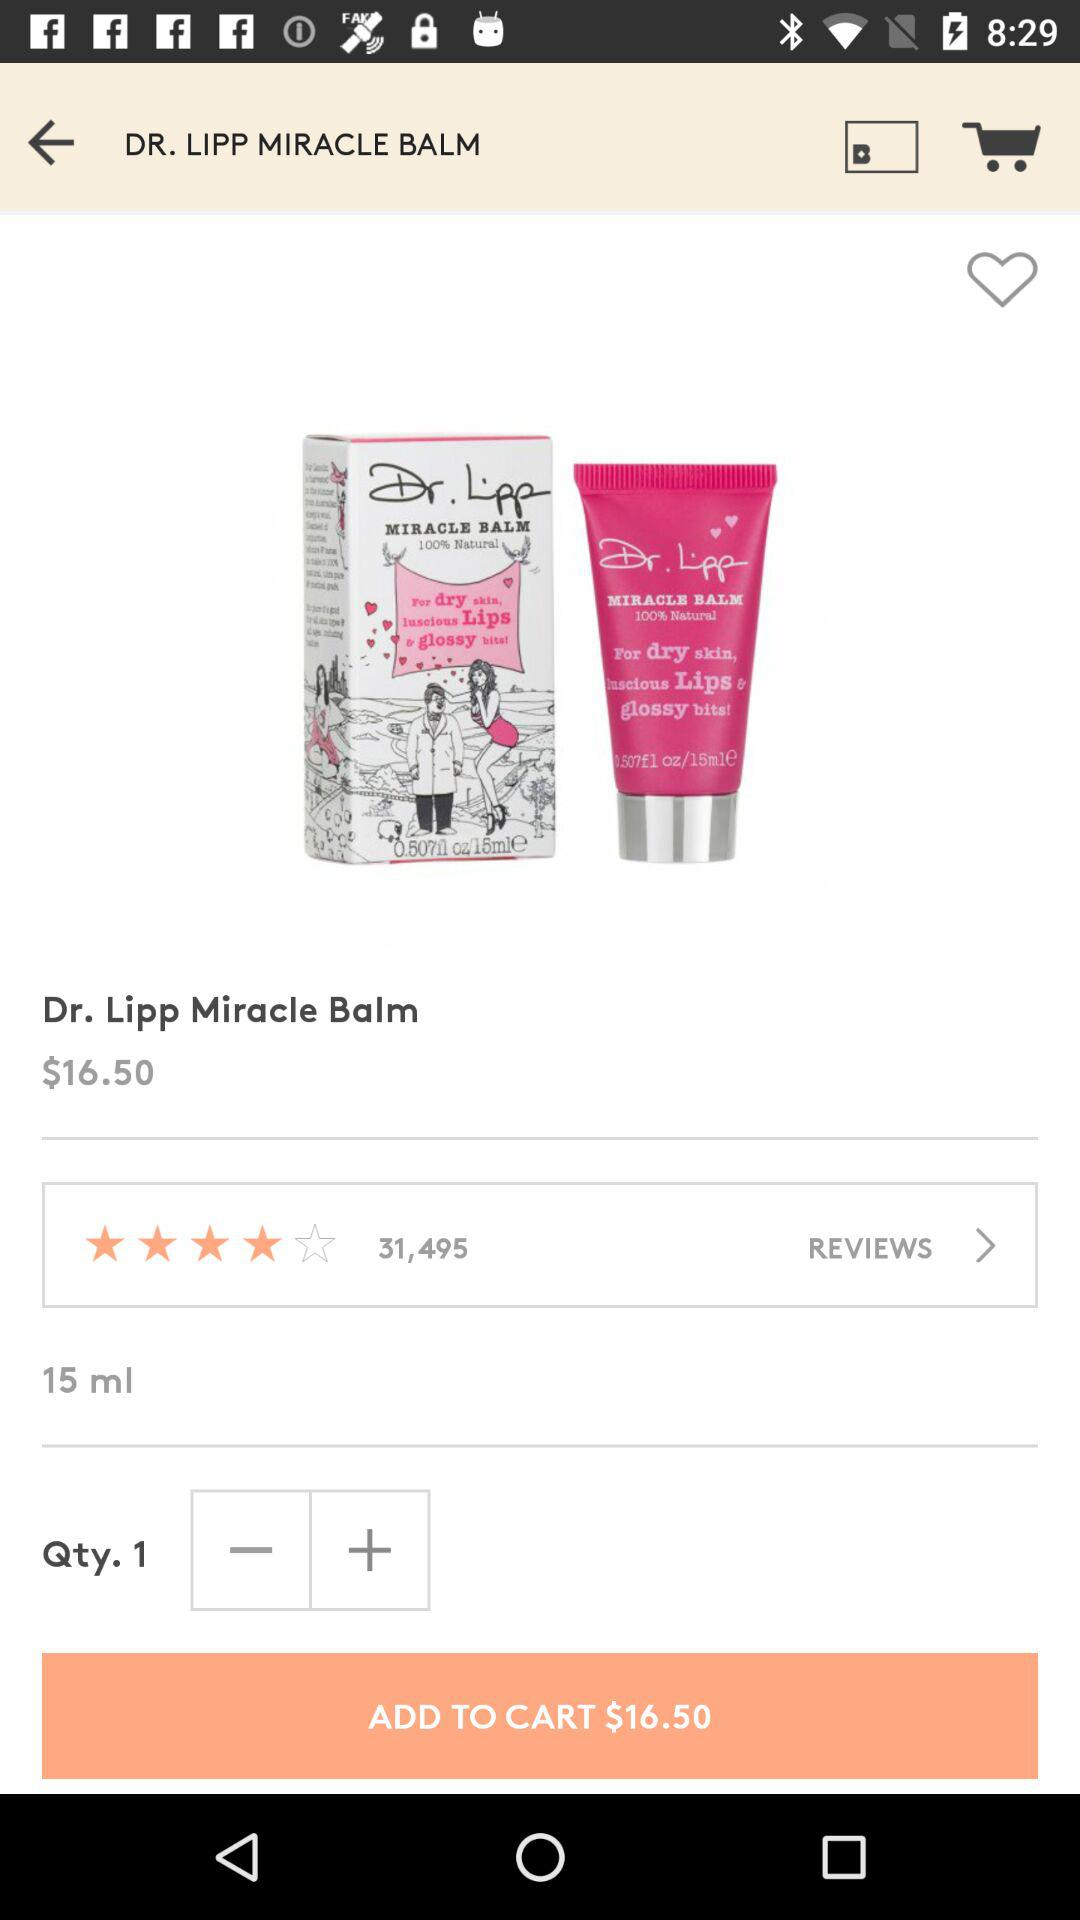What is the rating of the balm? The rating is 4 stars. 